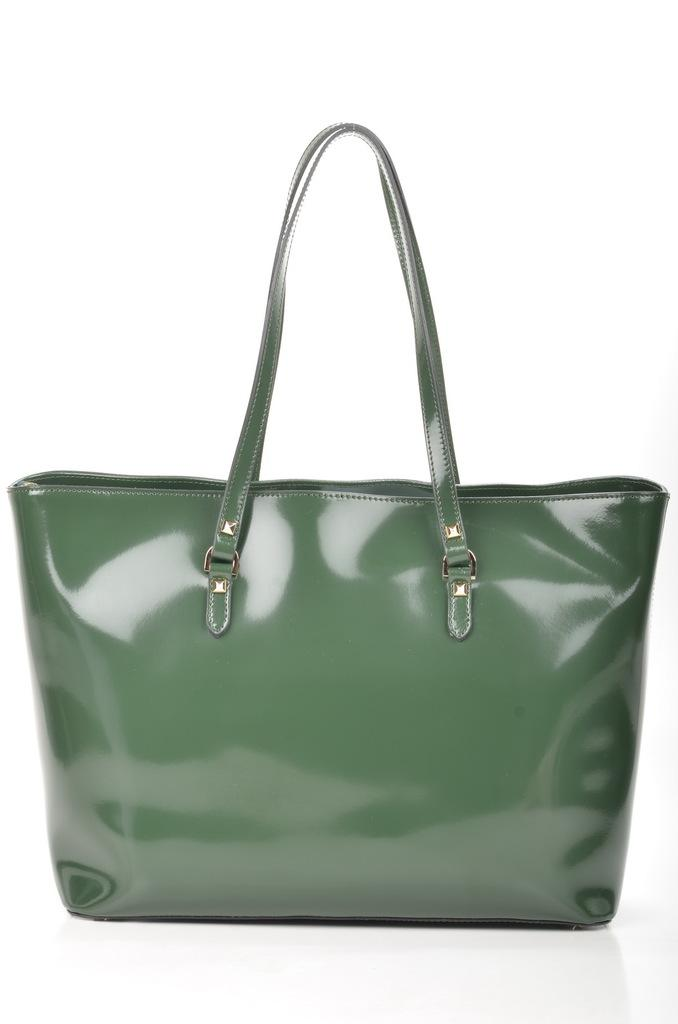What type of bag is visible in the image? There is a green bag with a handle in the image. How old is the baby in the image? There is no baby present in the image; it only features a green bag with a handle. 